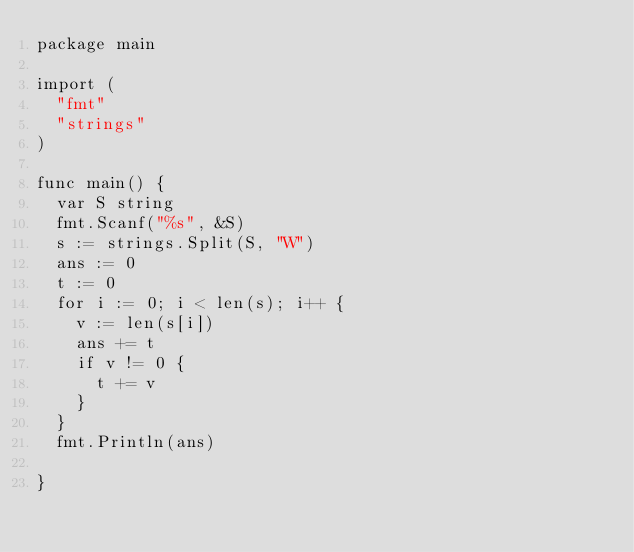<code> <loc_0><loc_0><loc_500><loc_500><_Go_>package main

import (
	"fmt"
	"strings"
)

func main() {
	var S string
	fmt.Scanf("%s", &S)
	s := strings.Split(S, "W")
	ans := 0
	t := 0
	for i := 0; i < len(s); i++ {
		v := len(s[i])
		ans += t
		if v != 0 {
			t += v
		}
	}
	fmt.Println(ans)

}
</code> 